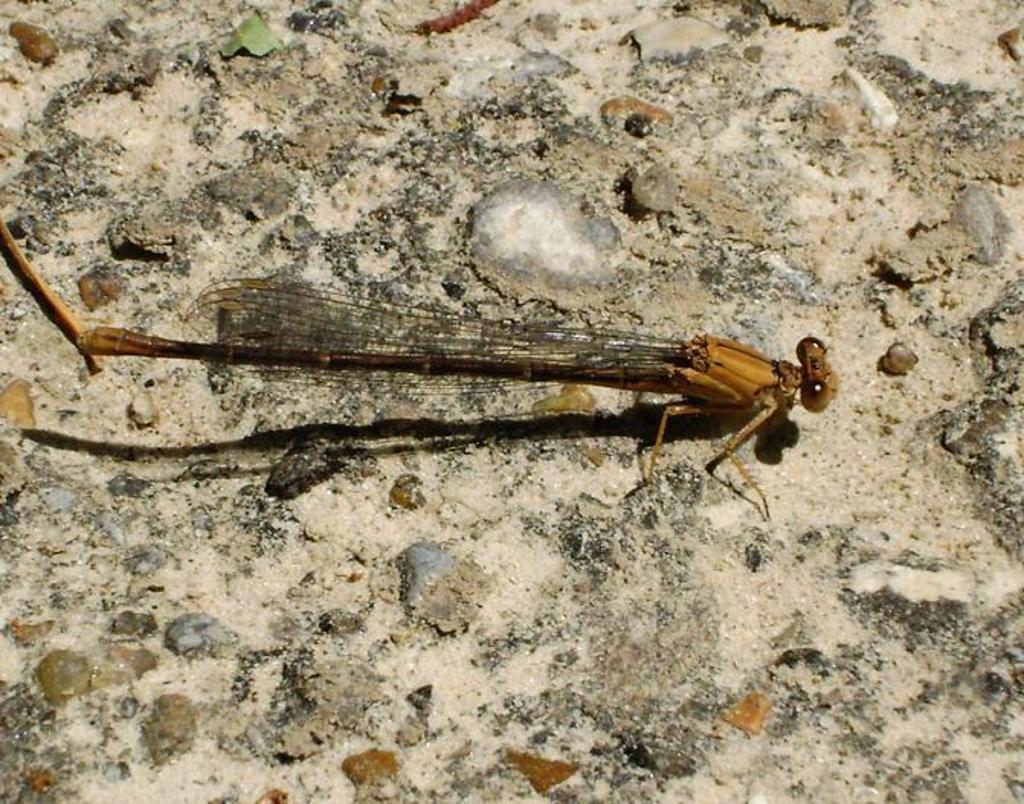How would you summarize this image in a sentence or two? In the picture there is a dragonfly represent on the floor. 